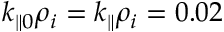Convert formula to latex. <formula><loc_0><loc_0><loc_500><loc_500>k _ { \| 0 } \rho _ { i } = k _ { \| } \rho _ { i } = 0 . 0 2</formula> 